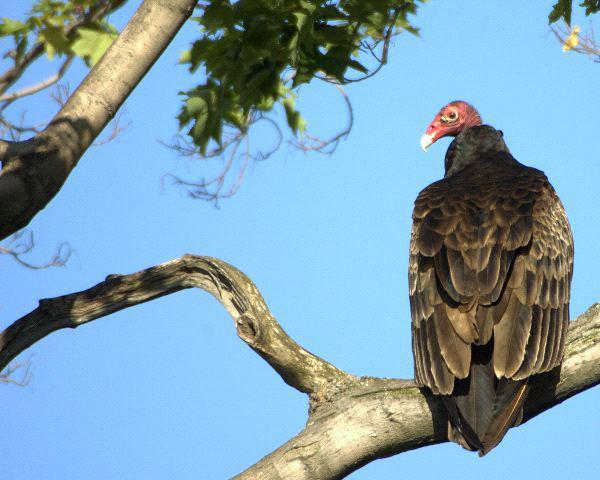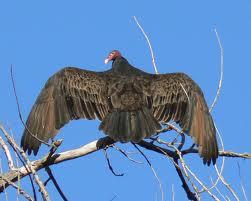The first image is the image on the left, the second image is the image on the right. Considering the images on both sides, is "There is one large bird with black and white feathers that has its wings spread." valid? Answer yes or no. No. The first image is the image on the left, the second image is the image on the right. Assess this claim about the two images: "Both turkey vultures are standing on a tree branch". Correct or not? Answer yes or no. Yes. 